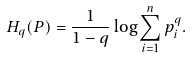Convert formula to latex. <formula><loc_0><loc_0><loc_500><loc_500>H _ { q } ( P ) = \frac { 1 } { 1 - q } \log \sum _ { i = 1 } ^ { n } p _ { i } ^ { q } .</formula> 